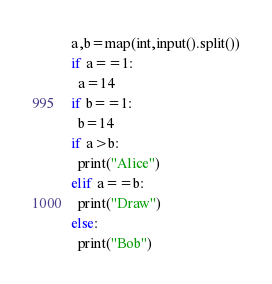Convert code to text. <code><loc_0><loc_0><loc_500><loc_500><_Python_>a,b=map(int,input().split())
if a==1:
  a=14
if b==1:
  b=14
if a>b:
  print("Alice")
elif a==b:
  print("Draw")
else:
  print("Bob")</code> 